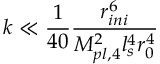Convert formula to latex. <formula><loc_0><loc_0><loc_500><loc_500>k \ll \frac { 1 } { 4 0 } \frac { r _ { i n i } ^ { 6 } } { M _ { p l , 4 } ^ { 2 } l _ { s } ^ { 4 } r _ { 0 } ^ { 4 } }</formula> 